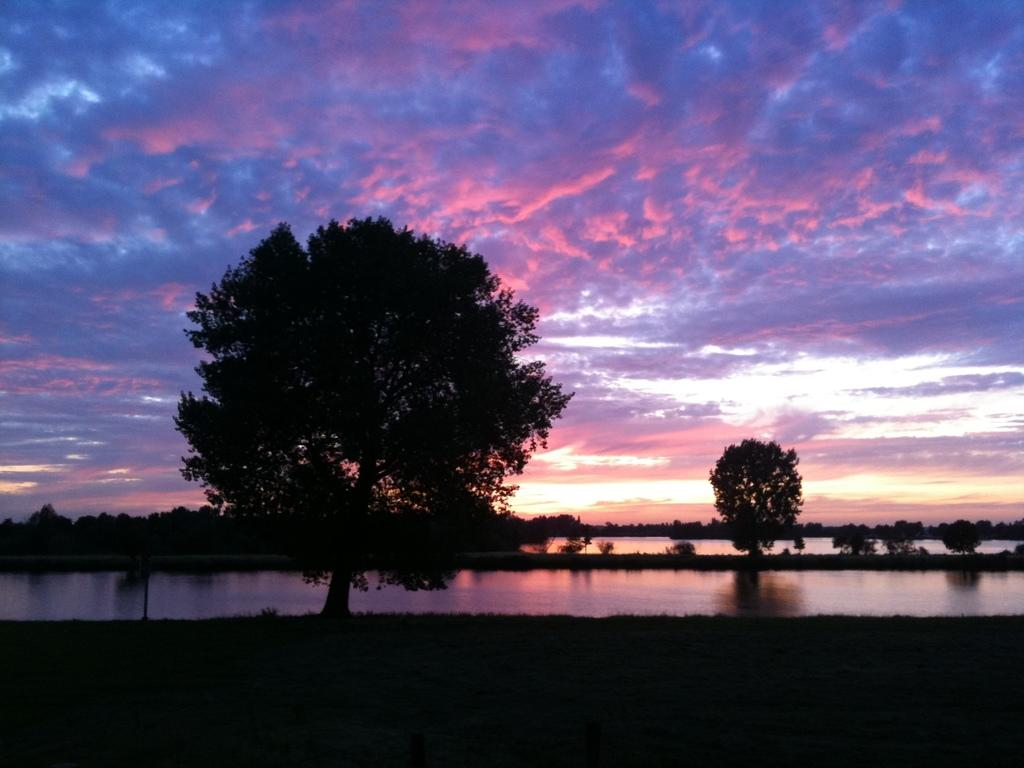What type of vegetation can be seen in the image? There are trees in the image. What else can be seen besides the trees? There is water visible in the image. What is visible in the background of the image? The sky is visible in the background of the image. Where is the clam located in the image? There is no clam present in the image. What does the mom do in the image? There is no reference to a mom or any person in the image. 